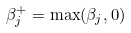Convert formula to latex. <formula><loc_0><loc_0><loc_500><loc_500>\beta _ { j } ^ { + } = \max ( \beta _ { j } , 0 )</formula> 